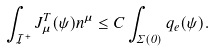Convert formula to latex. <formula><loc_0><loc_0><loc_500><loc_500>\int _ { \mathcal { I } ^ { + } } J _ { \mu } ^ { T } ( \psi ) n ^ { \mu } \leq C \int _ { \Sigma ( 0 ) } { q } _ { e } ( \psi ) .</formula> 